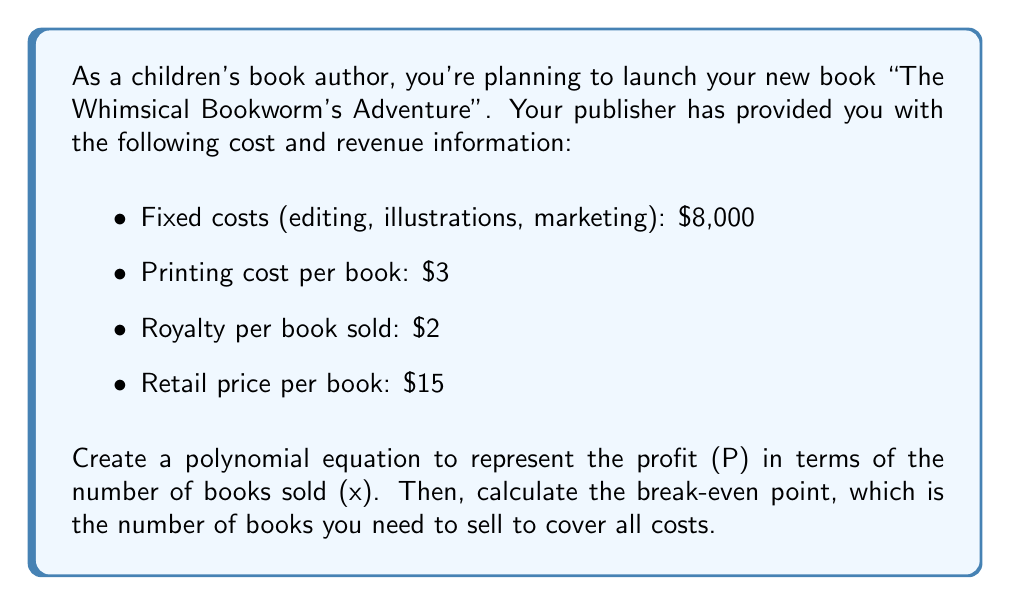Give your solution to this math problem. Let's approach this step-by-step:

1) First, let's identify the components of our profit equation:
   - Revenue: $15x (retail price × number of books sold)
   - Variable costs: $3x (printing cost × number of books sold)
   - Fixed costs: $8,000
   - Royalties: $2x (royalty per book × number of books sold)

2) The profit equation will be:
   $$ P = \text{Revenue} - \text{Variable Costs} - \text{Fixed Costs} - \text{Royalties} $$

3) Substituting our values:
   $$ P = 15x - 3x - 8000 - 2x $$

4) Simplifying:
   $$ P = 10x - 8000 $$

5) To find the break-even point, we set profit to zero:
   $$ 0 = 10x - 8000 $$

6) Solving for x:
   $$ 10x = 8000 $$
   $$ x = 800 $$

Therefore, you need to sell 800 books to break even.
Answer: 800 books 